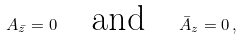<formula> <loc_0><loc_0><loc_500><loc_500>A _ { \bar { z } } = 0 \quad \text {and\quad } \bar { A } _ { z } = 0 \, ,</formula> 